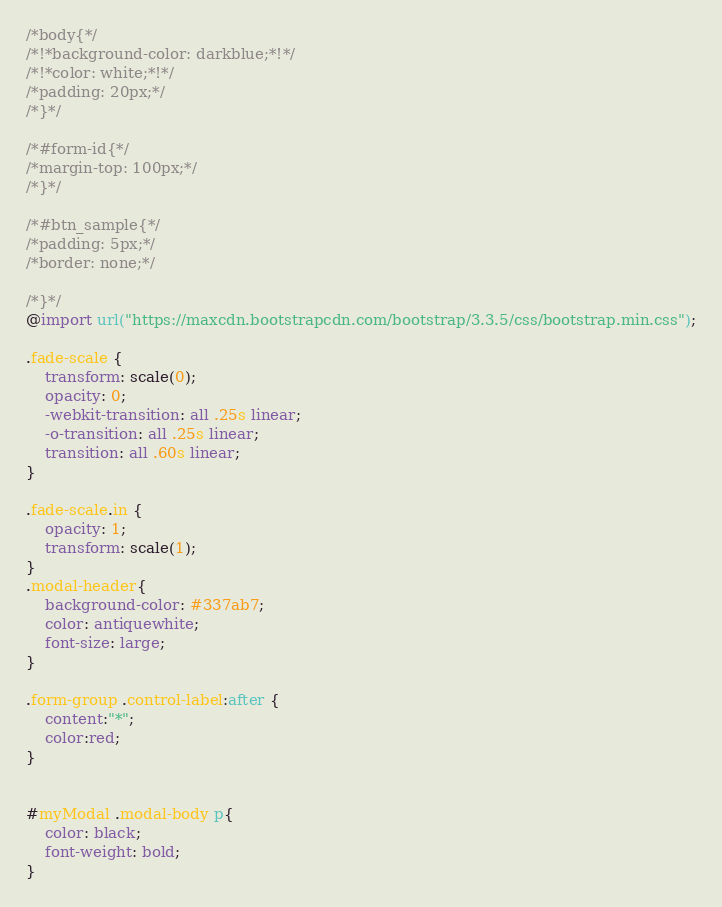Convert code to text. <code><loc_0><loc_0><loc_500><loc_500><_CSS_>/*body{*/
/*!*background-color: darkblue;*!*/
/*!*color: white;*!*/
/*padding: 20px;*/
/*}*/

/*#form-id{*/
/*margin-top: 100px;*/
/*}*/

/*#btn_sample{*/
/*padding: 5px;*/
/*border: none;*/

/*}*/
@import url("https://maxcdn.bootstrapcdn.com/bootstrap/3.3.5/css/bootstrap.min.css");

.fade-scale {
    transform: scale(0);
    opacity: 0;
    -webkit-transition: all .25s linear;
    -o-transition: all .25s linear;
    transition: all .60s linear;
}

.fade-scale.in {
    opacity: 1;
    transform: scale(1);
}
.modal-header{
    background-color: #337ab7;
    color: antiquewhite;
    font-size: large;
}

.form-group .control-label:after {
    content:"*";
    color:red;
}


#myModal .modal-body p{
    color: black;
    font-weight: bold;
}</code> 